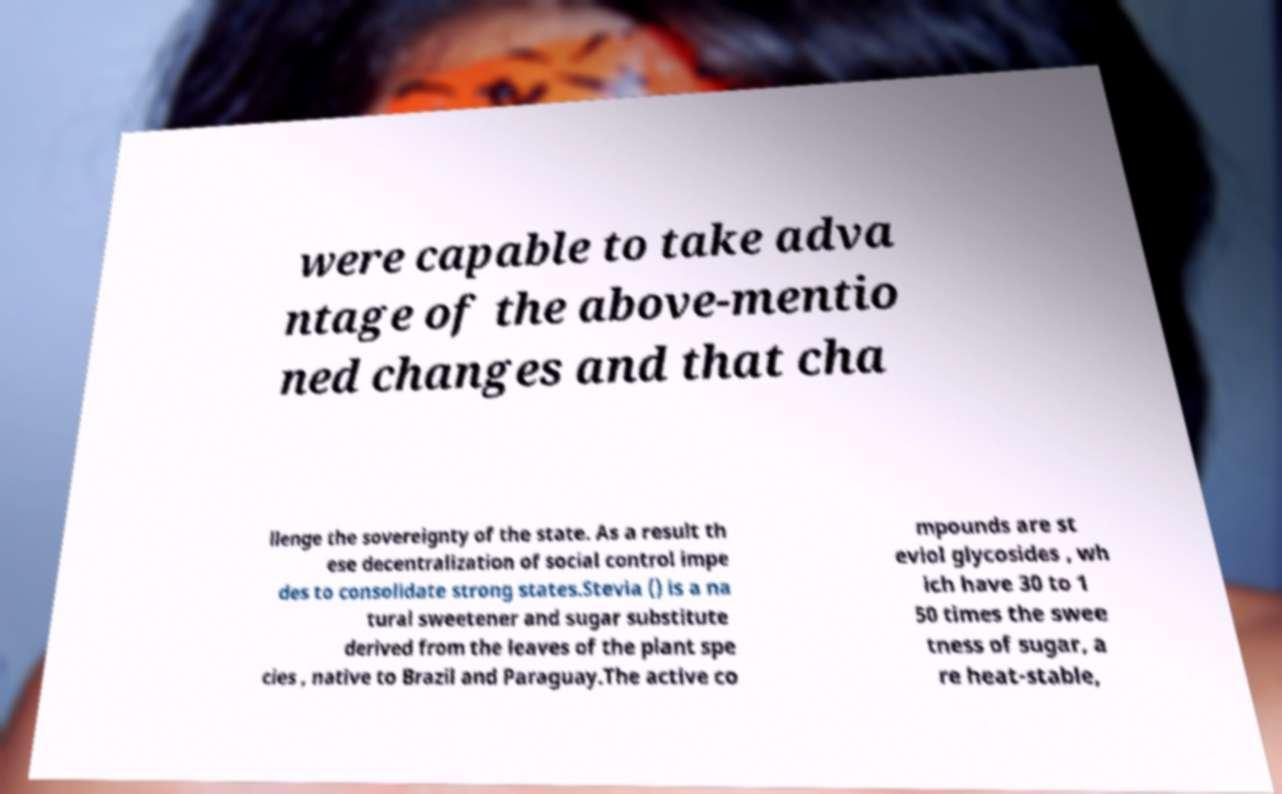What messages or text are displayed in this image? I need them in a readable, typed format. were capable to take adva ntage of the above-mentio ned changes and that cha llenge the sovereignty of the state. As a result th ese decentralization of social control impe des to consolidate strong states.Stevia () is a na tural sweetener and sugar substitute derived from the leaves of the plant spe cies , native to Brazil and Paraguay.The active co mpounds are st eviol glycosides , wh ich have 30 to 1 50 times the swee tness of sugar, a re heat-stable, 